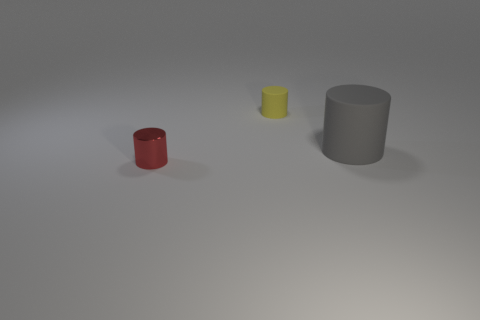Could you describe the lighting and shadows in the scene? The lighting in the image appears to be coming from the upper left, casting soft, diffuse shadows towards the right of the objects. The shadows are subtle and help provide a sense of depth and dimension to the scene. 